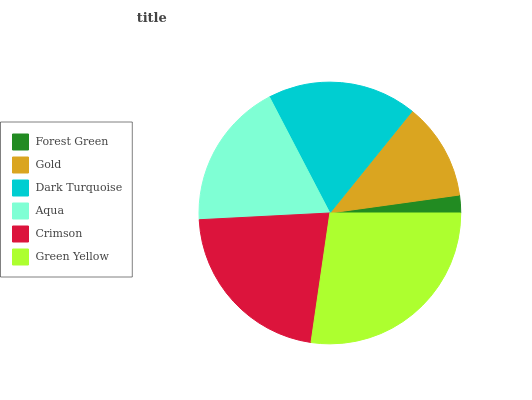Is Forest Green the minimum?
Answer yes or no. Yes. Is Green Yellow the maximum?
Answer yes or no. Yes. Is Gold the minimum?
Answer yes or no. No. Is Gold the maximum?
Answer yes or no. No. Is Gold greater than Forest Green?
Answer yes or no. Yes. Is Forest Green less than Gold?
Answer yes or no. Yes. Is Forest Green greater than Gold?
Answer yes or no. No. Is Gold less than Forest Green?
Answer yes or no. No. Is Dark Turquoise the high median?
Answer yes or no. Yes. Is Aqua the low median?
Answer yes or no. Yes. Is Gold the high median?
Answer yes or no. No. Is Forest Green the low median?
Answer yes or no. No. 